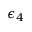Convert formula to latex. <formula><loc_0><loc_0><loc_500><loc_500>\epsilon _ { 4 }</formula> 